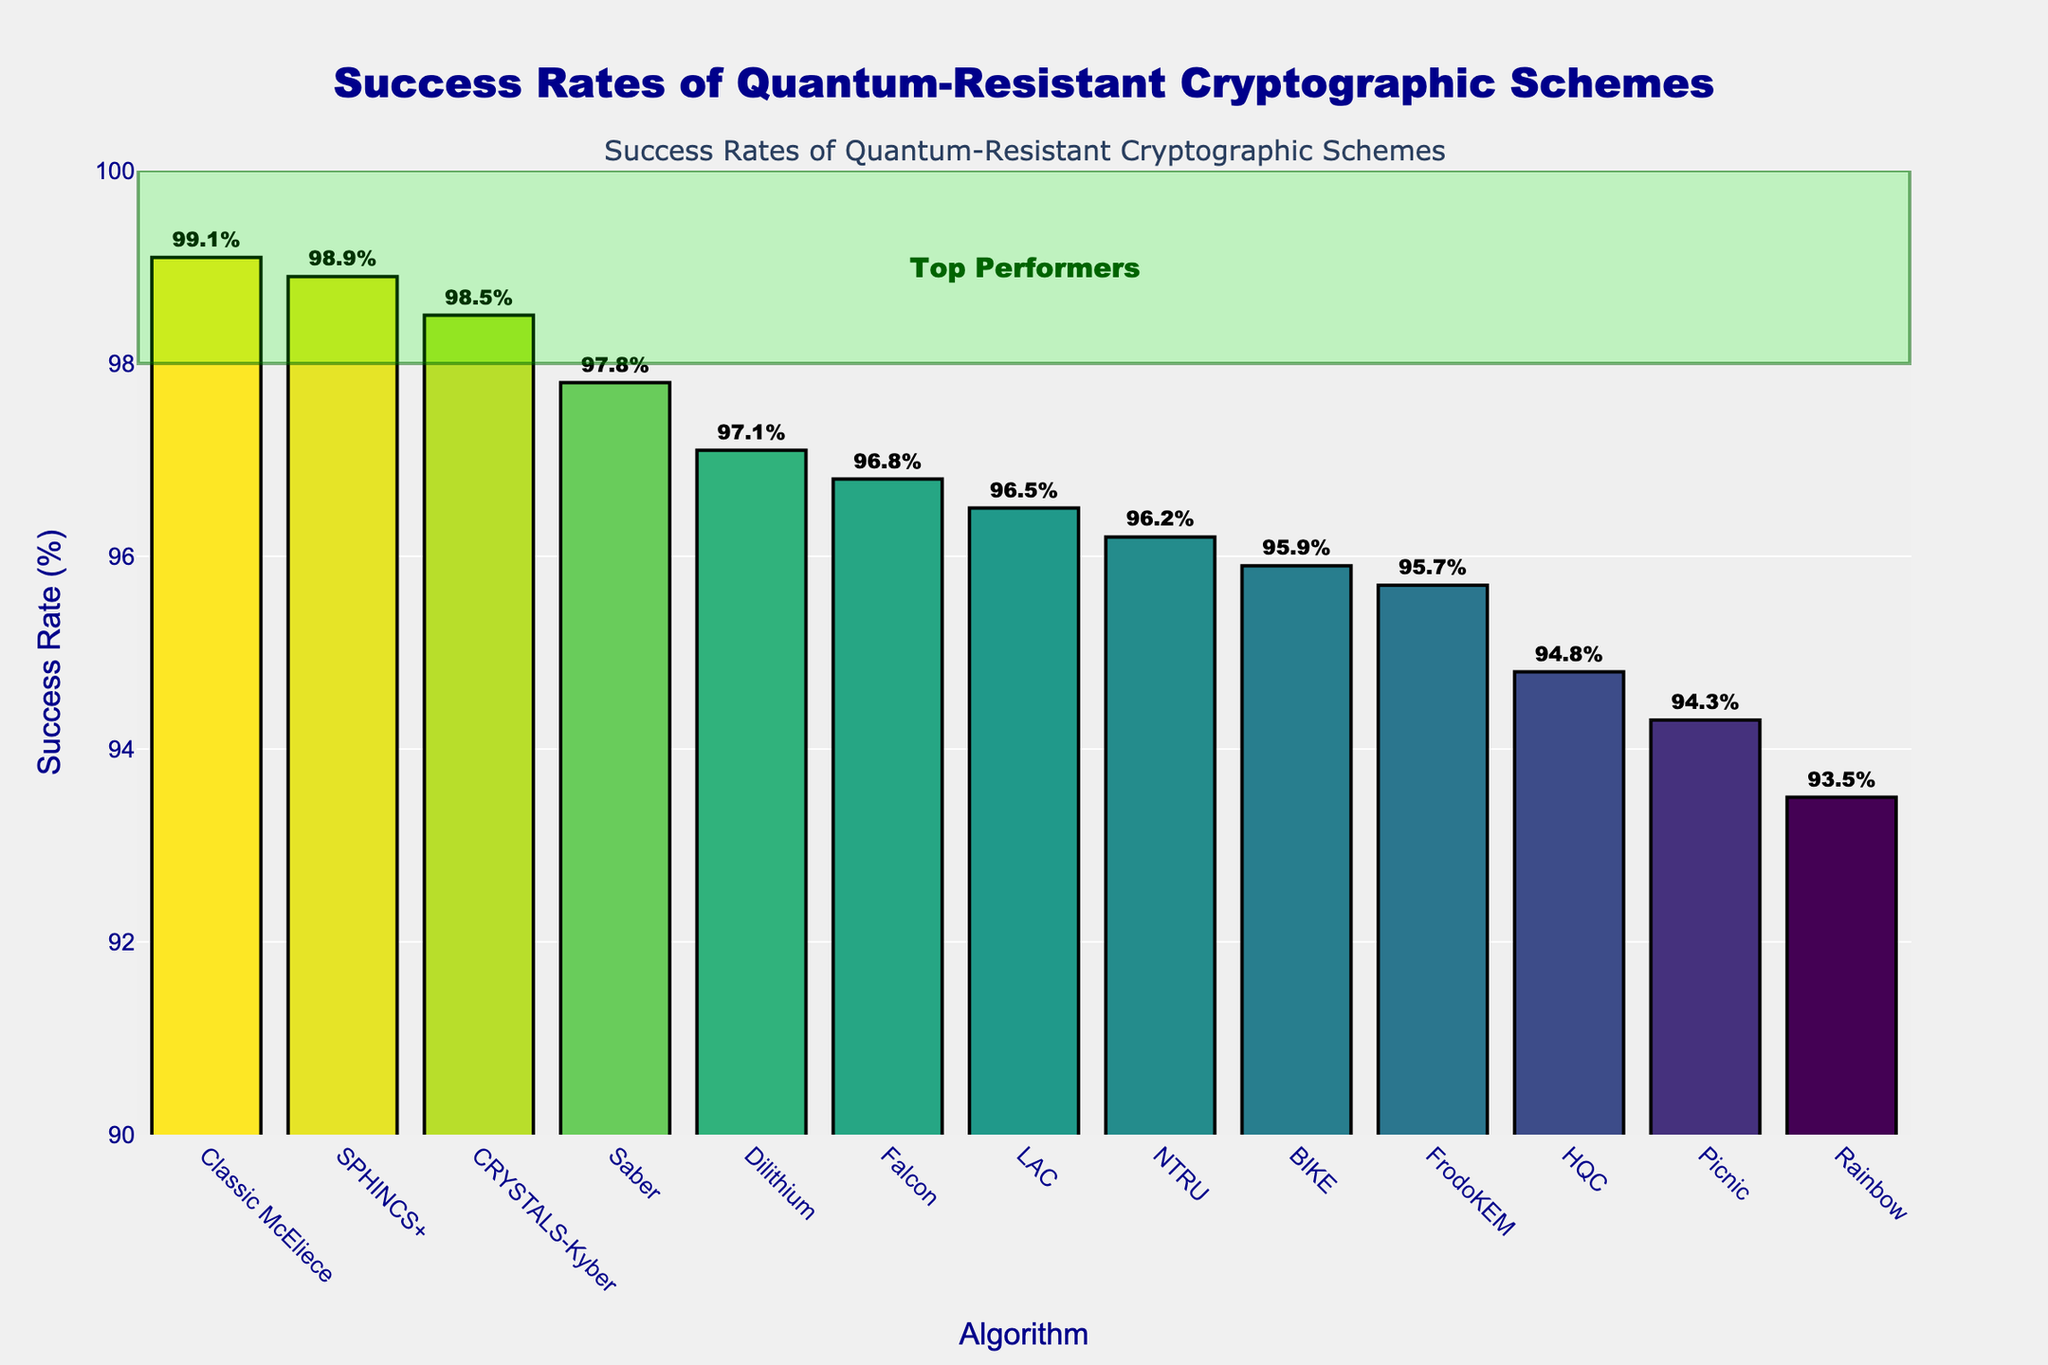What is the success rate of the quantum-resistant cryptographic scheme Classic McEliece? The figure shows a bar chart where each bar represents the success rate of a cryptographic scheme. The success rate for Classic McEliece is annotated outside the bar.
Answer: 99.1% Which cryptographic scheme has the lowest success rate? By comparing the heights of the bars in the figure, the shortest bar represents the scheme with the lowest success rate. That bar corresponds to the Rainbow scheme.
Answer: Rainbow How many cryptographic schemes have a success rate above 97%? Count the number of bars that extend above the 97% mark. The annotations outside the bars help to identify these bars.
Answer: 6 Which cryptographic schemes fall in the "Top Performers" category? The "Top Performers" category is highlighted between the 98% and 100% range. The bars within this highlighted rectangle have their success rates annotated outside. These schemes are Classic McEliece, SPHINCS+, and CRYSTALS-Kyber.
Answer: Classic McEliece, SPHINCS+, CRYSTALS-Kyber What is the success rate difference between CRYSTALS-Kyber and Falcon? Refer to the annotations outside the bars for CRYSTALS-Kyber and Falcon. Subtract the success rate of Falcon from that of CRYSTALS-Kyber: 98.5% - 96.8%
Answer: 1.7% Which cryptographic scheme has a success rate closest to 95%? Look for the bar with a success rate closest to 95% by referring to the annotations. The scheme with the success rate closest to 95% is FrodoKEM with 95.7%.
Answer: FrodoKEM Compare the success rates of Dilithium and SPHINCS+. Which one performs better and by how much? The success rates are annotated outside the bars. Dilithium has a success rate of 97.1%, and SPHINCS+ has a success rate of 98.9%. Subtract Dilithium’s success rate from SPHINCS+’s: 98.9% - 97.1%
Answer: SPHINCS+ by 1.8% What is the average success rate of the top three performing schemes? Identify the top three schemes based on the success rates annotated: Classic McEliece (99.1%), SPHINCS+ (98.9%), and CRYSTALS-Kyber (98.5%). Calculate the average: (99.1 + 98.9 + 98.5) / 3
Answer: 98.83% Are there any cryptographic schemes with success rates exactly equal to the average success rate of 96%? From the annotations, check if any bar has a success rate of exactly 96%. None of the schemes have a success rate exactly equal to the average of 96%.
Answer: No 